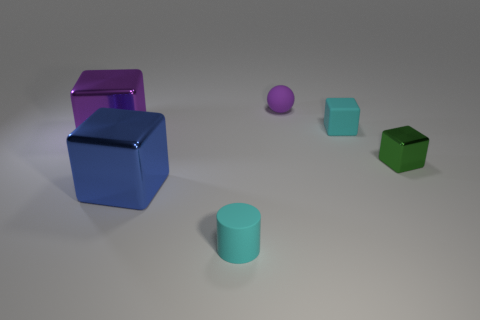Subtract all green cubes. How many cubes are left? 3 Add 3 large cyan cylinders. How many objects exist? 9 Subtract all gray blocks. Subtract all cyan cylinders. How many blocks are left? 4 Subtract all cubes. How many objects are left? 2 Subtract 1 cyan cylinders. How many objects are left? 5 Subtract all large blue metallic spheres. Subtract all cyan rubber cubes. How many objects are left? 5 Add 5 purple objects. How many purple objects are left? 7 Add 2 rubber cubes. How many rubber cubes exist? 3 